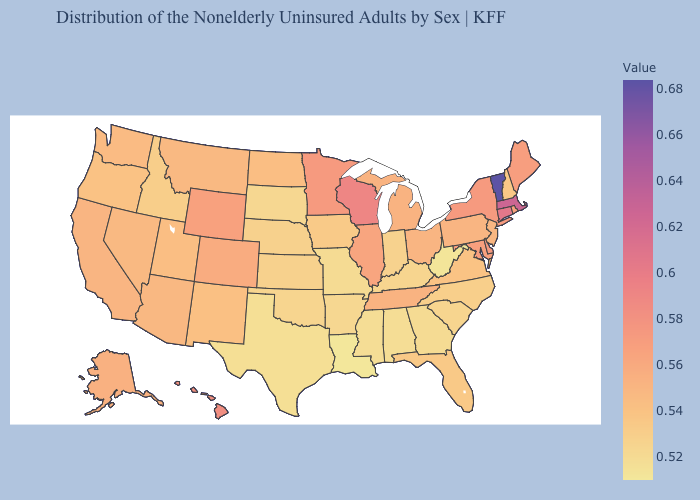Among the states that border Georgia , does Tennessee have the highest value?
Answer briefly. Yes. Does Minnesota have a higher value than Alabama?
Be succinct. Yes. Does Washington have a higher value than Wisconsin?
Concise answer only. No. Which states have the lowest value in the West?
Be succinct. Idaho. Which states have the lowest value in the USA?
Answer briefly. Louisiana. 